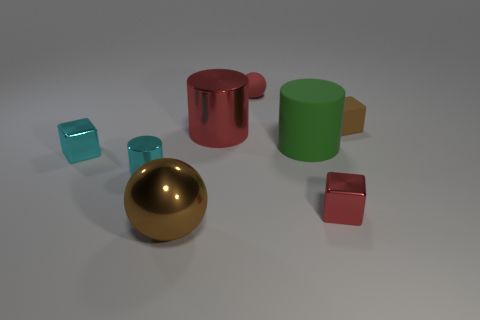Subtract all tiny metal blocks. How many blocks are left? 1 Add 1 brown objects. How many objects exist? 9 Subtract all tiny cyan shiny balls. Subtract all tiny red objects. How many objects are left? 6 Add 6 small brown rubber objects. How many small brown rubber objects are left? 7 Add 4 large objects. How many large objects exist? 7 Subtract 1 cyan cylinders. How many objects are left? 7 Subtract all blocks. How many objects are left? 5 